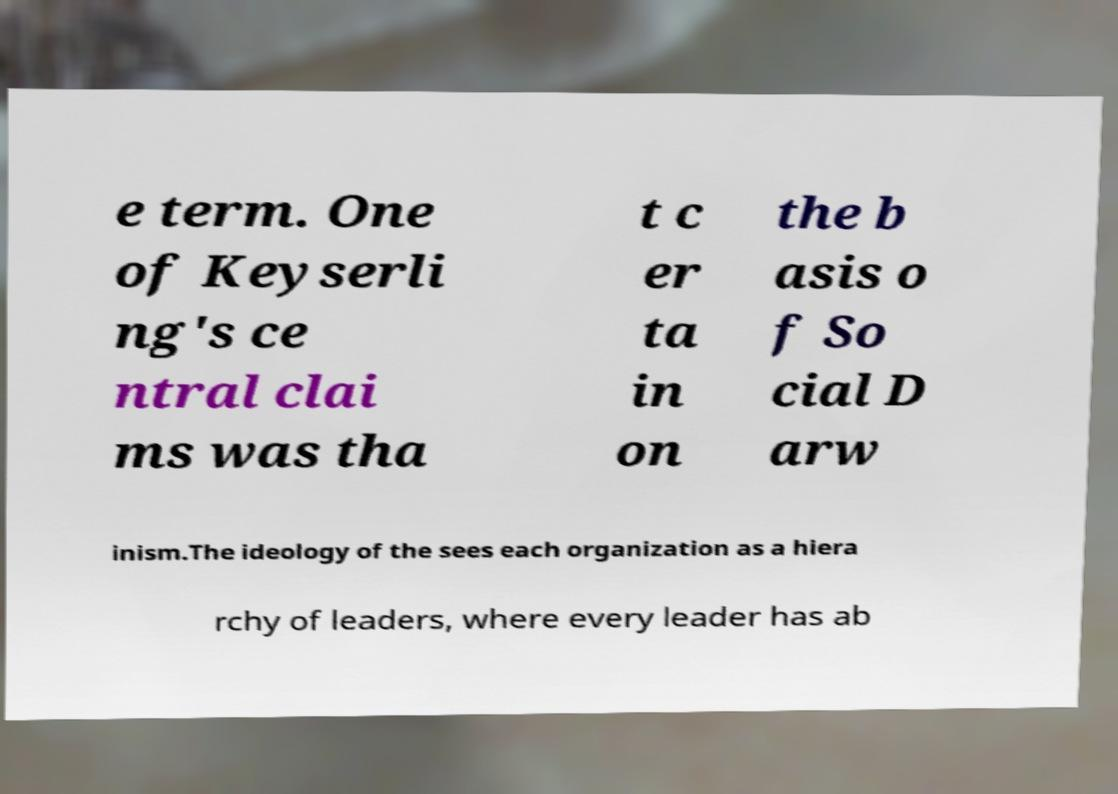Please identify and transcribe the text found in this image. e term. One of Keyserli ng's ce ntral clai ms was tha t c er ta in on the b asis o f So cial D arw inism.The ideology of the sees each organization as a hiera rchy of leaders, where every leader has ab 